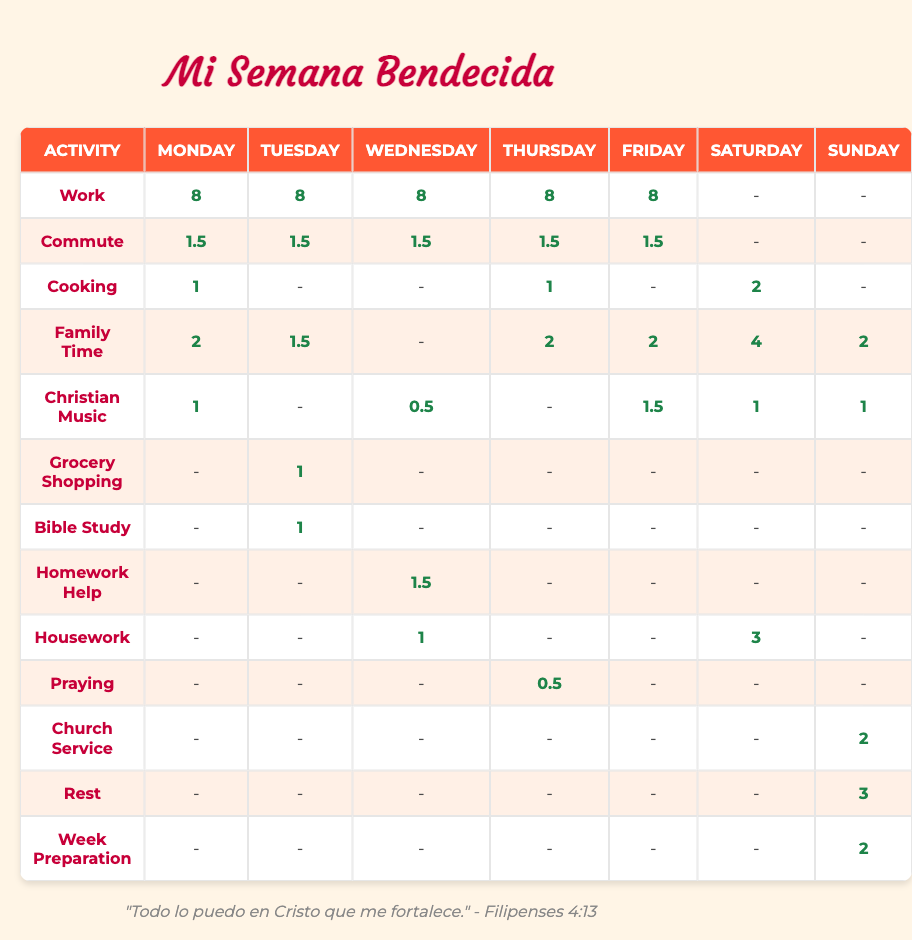What is the total number of hours spent on Family Time on weekdays? To find the total hours spent on Family Time during weekdays (Monday to Friday), I will look at the values in the Family Time row for those days: 2 (Monday) + 1.5 (Tuesday) + 0 (Wednesday) + 2 (Thursday) + 2 (Friday) = 8.5 hours.
Answer: 8.5 Which day has the least hours allocated to Listening to Christian music? I will review the Listening to Christian music row and look at the hours for each day: 1 (Monday), 0 (Tuesday), 0.5 (Wednesday), 0 (Thursday), 1.5 (Friday), 1 (Saturday), 1 (Sunday). The least is 0 hours on Tuesday and Thursday.
Answer: 0 hours Did the mother spend more time cooking on Saturday than on Thursday? To determine this, I will compare the hours for Cooking on both days. Cooking hours on Saturday is 2, and on Thursday, it is 1. Since 2 is greater than 1, the answer is yes.
Answer: Yes What is the average time allocated to commuting throughout the week? I will sum the commuting hours for each weekday: 1.5 (Monday) + 1.5 (Tuesday) + 1.5 (Wednesday) + 1.5 (Thursday) + 1.5 (Friday) = 7.5 hours. There are 5 days, so the average is 7.5/5 = 1.5 hours.
Answer: 1.5 On which day does the mother spend the most hours on Rest? Reviewing the Rest row, I find there are 3 hours on Sunday. No other day has allocated hours for Rest, so Sunday is the day with the most hours for this activity.
Answer: Sunday 